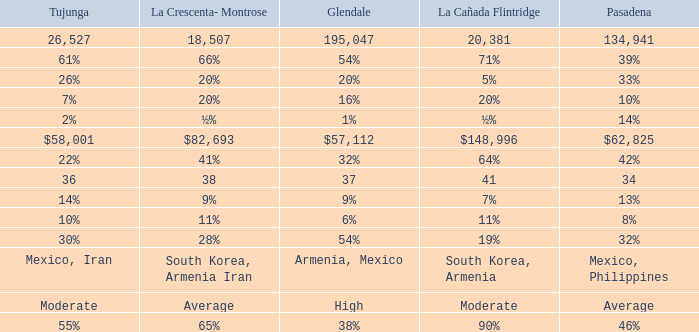What is the percentage of Tukunga when La Crescenta-Montrose is 28%? 30%. 